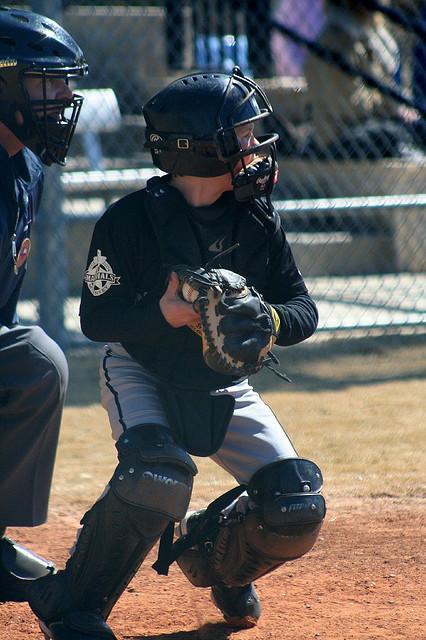How many people are there?
Give a very brief answer. 2. 